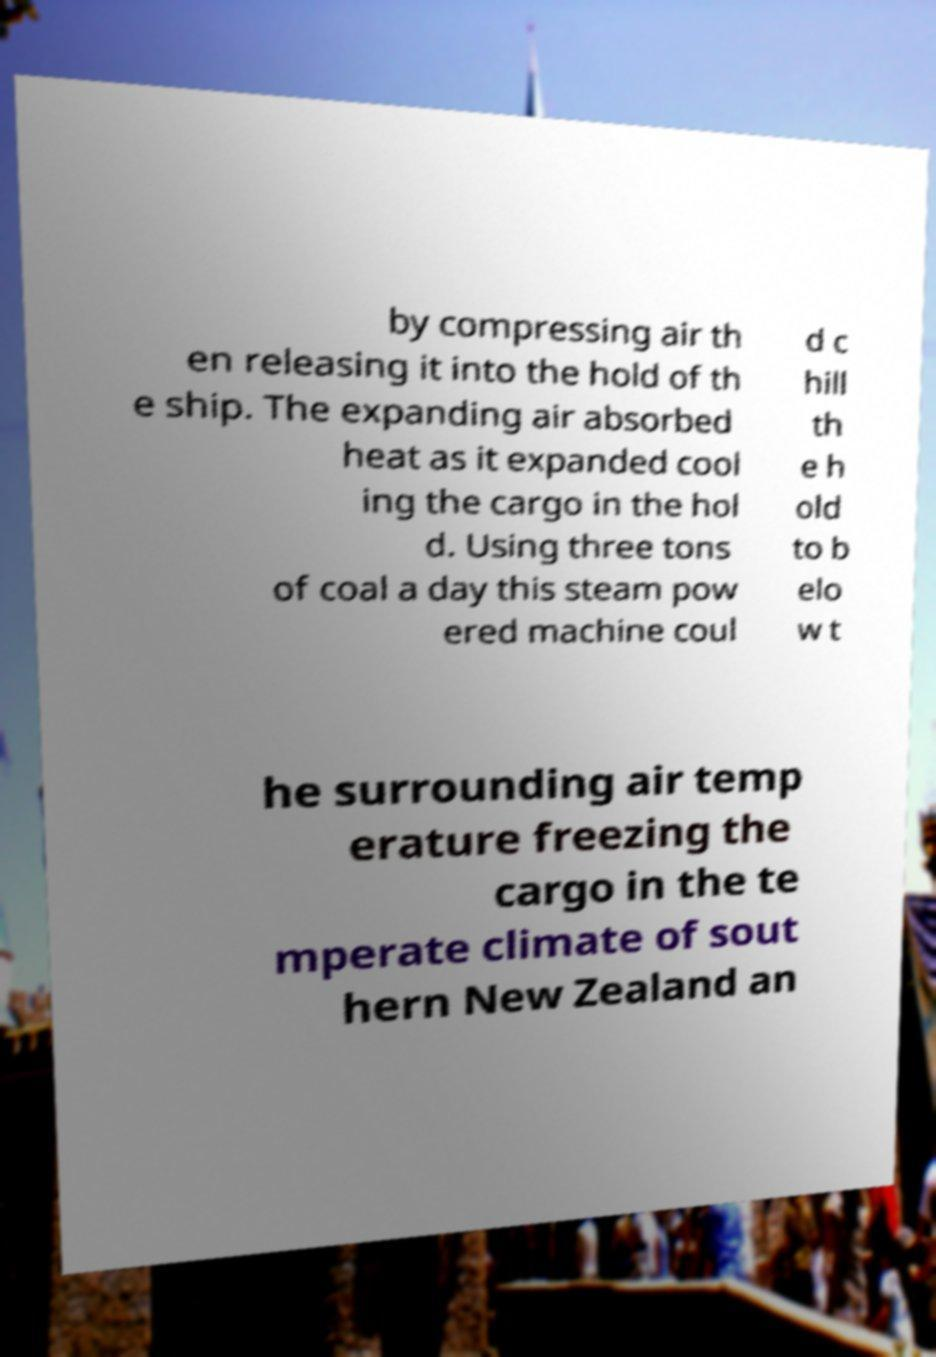I need the written content from this picture converted into text. Can you do that? by compressing air th en releasing it into the hold of th e ship. The expanding air absorbed heat as it expanded cool ing the cargo in the hol d. Using three tons of coal a day this steam pow ered machine coul d c hill th e h old to b elo w t he surrounding air temp erature freezing the cargo in the te mperate climate of sout hern New Zealand an 